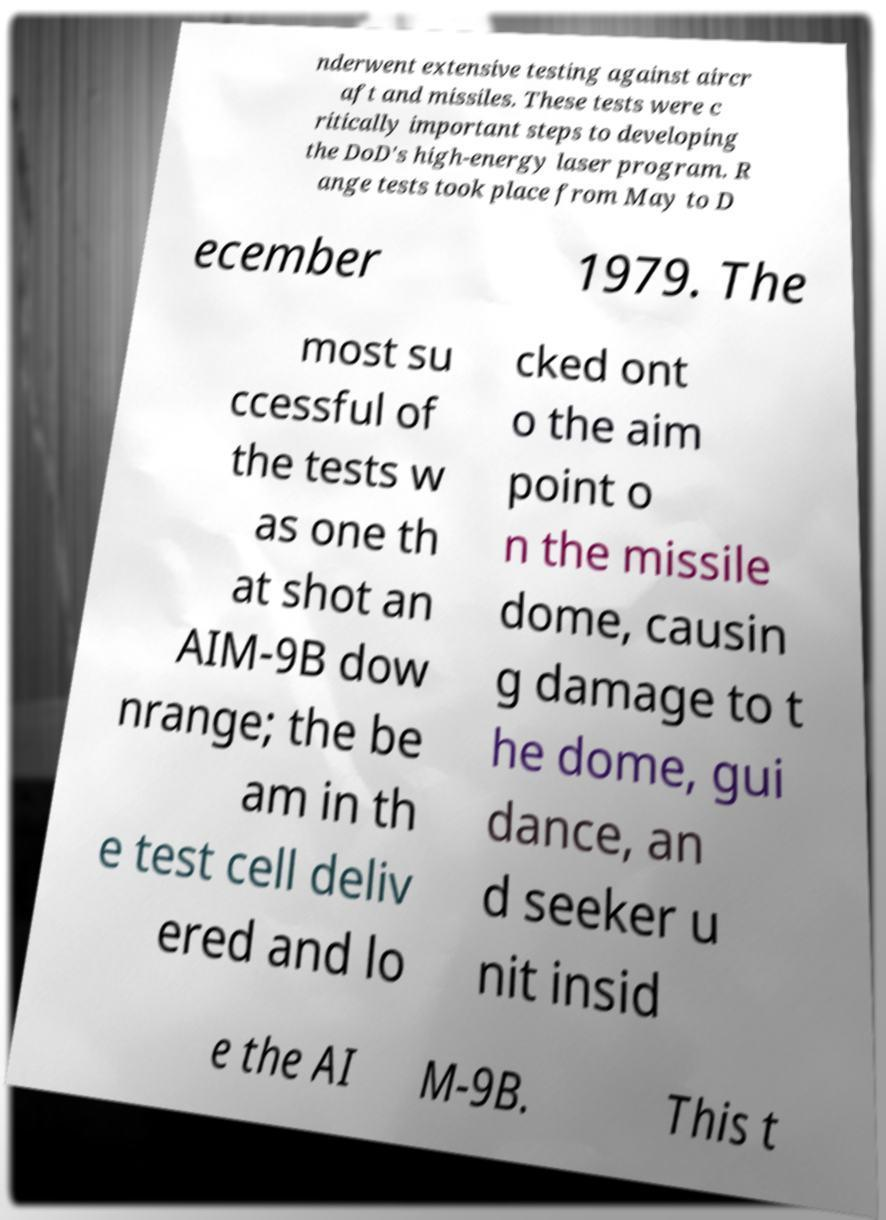There's text embedded in this image that I need extracted. Can you transcribe it verbatim? nderwent extensive testing against aircr aft and missiles. These tests were c ritically important steps to developing the DoD's high-energy laser program. R ange tests took place from May to D ecember 1979. The most su ccessful of the tests w as one th at shot an AIM-9B dow nrange; the be am in th e test cell deliv ered and lo cked ont o the aim point o n the missile dome, causin g damage to t he dome, gui dance, an d seeker u nit insid e the AI M-9B. This t 